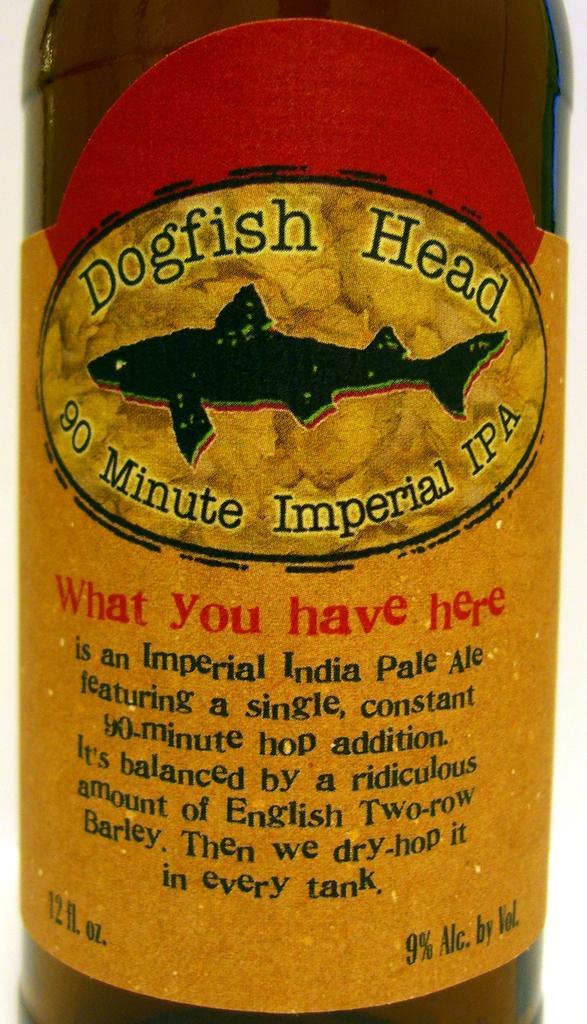Describe this image in one or two sentences. In this image I can see sticker is on the object. Something is written on the object. 